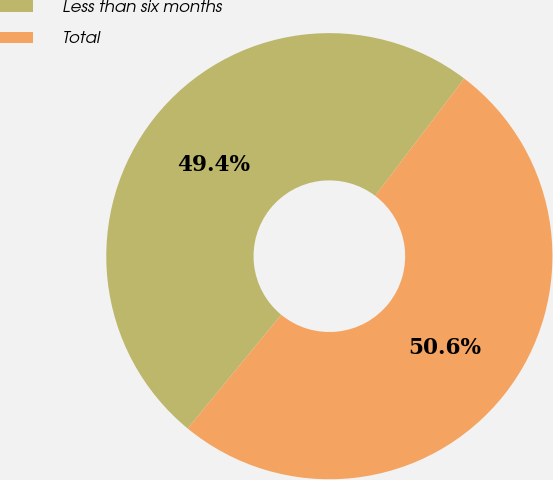Convert chart to OTSL. <chart><loc_0><loc_0><loc_500><loc_500><pie_chart><fcel>Less than six months<fcel>Total<nl><fcel>49.38%<fcel>50.62%<nl></chart> 